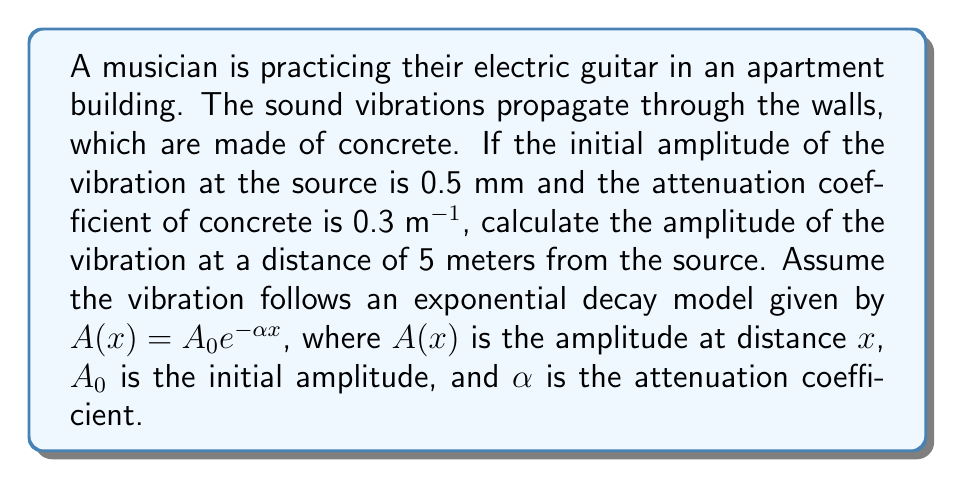Can you answer this question? Let's solve this problem step by step:

1. Identify the given information:
   - Initial amplitude, $A_0 = 0.5$ mm
   - Attenuation coefficient of concrete, $\alpha = 0.3$ m^(-1)
   - Distance from the source, $x = 5$ m

2. The model for exponential decay of vibration amplitude is:
   $A(x) = A_0e^{-\alpha x}$

3. Substitute the known values into the equation:
   $A(5) = 0.5e^{-0.3 \cdot 5}$

4. Calculate the exponent:
   $-0.3 \cdot 5 = -1.5$

5. Simplify the equation:
   $A(5) = 0.5e^{-1.5}$

6. Calculate $e^{-1.5}$ (you can use a calculator for this):
   $e^{-1.5} \approx 0.2231$

7. Multiply by the initial amplitude:
   $A(5) = 0.5 \cdot 0.2231 \approx 0.1116$ mm

8. Round to three decimal places:
   $A(5) \approx 0.112$ mm

Therefore, the amplitude of the vibration at a distance of 5 meters from the source is approximately 0.112 mm.
Answer: 0.112 mm 